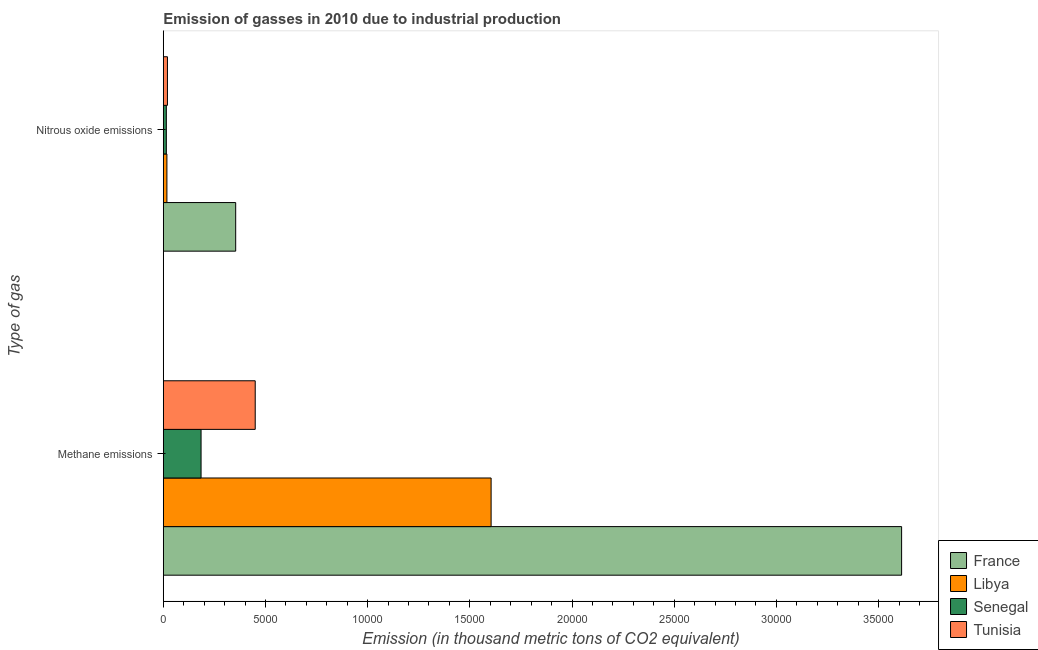Are the number of bars per tick equal to the number of legend labels?
Give a very brief answer. Yes. What is the label of the 1st group of bars from the top?
Ensure brevity in your answer.  Nitrous oxide emissions. What is the amount of nitrous oxide emissions in Tunisia?
Provide a short and direct response. 203.3. Across all countries, what is the maximum amount of nitrous oxide emissions?
Give a very brief answer. 3541.9. Across all countries, what is the minimum amount of methane emissions?
Keep it short and to the point. 1848. In which country was the amount of nitrous oxide emissions minimum?
Your response must be concise. Senegal. What is the total amount of nitrous oxide emissions in the graph?
Give a very brief answer. 4070.4. What is the difference between the amount of nitrous oxide emissions in France and that in Senegal?
Keep it short and to the point. 3393.3. What is the difference between the amount of nitrous oxide emissions in Libya and the amount of methane emissions in France?
Offer a very short reply. -3.59e+04. What is the average amount of nitrous oxide emissions per country?
Make the answer very short. 1017.6. What is the difference between the amount of methane emissions and amount of nitrous oxide emissions in Senegal?
Offer a terse response. 1699.4. What is the ratio of the amount of nitrous oxide emissions in France to that in Libya?
Provide a succinct answer. 20.06. Is the amount of methane emissions in Libya less than that in France?
Your answer should be very brief. Yes. In how many countries, is the amount of nitrous oxide emissions greater than the average amount of nitrous oxide emissions taken over all countries?
Give a very brief answer. 1. What does the 1st bar from the top in Methane emissions represents?
Offer a very short reply. Tunisia. What does the 2nd bar from the bottom in Nitrous oxide emissions represents?
Keep it short and to the point. Libya. How many bars are there?
Ensure brevity in your answer.  8. What is the difference between two consecutive major ticks on the X-axis?
Make the answer very short. 5000. Does the graph contain any zero values?
Give a very brief answer. No. How many legend labels are there?
Your answer should be compact. 4. What is the title of the graph?
Your answer should be compact. Emission of gasses in 2010 due to industrial production. Does "Trinidad and Tobago" appear as one of the legend labels in the graph?
Offer a very short reply. No. What is the label or title of the X-axis?
Provide a short and direct response. Emission (in thousand metric tons of CO2 equivalent). What is the label or title of the Y-axis?
Give a very brief answer. Type of gas. What is the Emission (in thousand metric tons of CO2 equivalent) in France in Methane emissions?
Provide a succinct answer. 3.61e+04. What is the Emission (in thousand metric tons of CO2 equivalent) in Libya in Methane emissions?
Ensure brevity in your answer.  1.60e+04. What is the Emission (in thousand metric tons of CO2 equivalent) of Senegal in Methane emissions?
Your response must be concise. 1848. What is the Emission (in thousand metric tons of CO2 equivalent) of Tunisia in Methane emissions?
Provide a short and direct response. 4497.8. What is the Emission (in thousand metric tons of CO2 equivalent) of France in Nitrous oxide emissions?
Ensure brevity in your answer.  3541.9. What is the Emission (in thousand metric tons of CO2 equivalent) of Libya in Nitrous oxide emissions?
Your answer should be very brief. 176.6. What is the Emission (in thousand metric tons of CO2 equivalent) in Senegal in Nitrous oxide emissions?
Make the answer very short. 148.6. What is the Emission (in thousand metric tons of CO2 equivalent) of Tunisia in Nitrous oxide emissions?
Your answer should be compact. 203.3. Across all Type of gas, what is the maximum Emission (in thousand metric tons of CO2 equivalent) in France?
Offer a terse response. 3.61e+04. Across all Type of gas, what is the maximum Emission (in thousand metric tons of CO2 equivalent) of Libya?
Offer a very short reply. 1.60e+04. Across all Type of gas, what is the maximum Emission (in thousand metric tons of CO2 equivalent) in Senegal?
Give a very brief answer. 1848. Across all Type of gas, what is the maximum Emission (in thousand metric tons of CO2 equivalent) in Tunisia?
Provide a succinct answer. 4497.8. Across all Type of gas, what is the minimum Emission (in thousand metric tons of CO2 equivalent) in France?
Your response must be concise. 3541.9. Across all Type of gas, what is the minimum Emission (in thousand metric tons of CO2 equivalent) in Libya?
Your response must be concise. 176.6. Across all Type of gas, what is the minimum Emission (in thousand metric tons of CO2 equivalent) in Senegal?
Provide a succinct answer. 148.6. Across all Type of gas, what is the minimum Emission (in thousand metric tons of CO2 equivalent) of Tunisia?
Offer a very short reply. 203.3. What is the total Emission (in thousand metric tons of CO2 equivalent) of France in the graph?
Your answer should be very brief. 3.97e+04. What is the total Emission (in thousand metric tons of CO2 equivalent) of Libya in the graph?
Give a very brief answer. 1.62e+04. What is the total Emission (in thousand metric tons of CO2 equivalent) of Senegal in the graph?
Keep it short and to the point. 1996.6. What is the total Emission (in thousand metric tons of CO2 equivalent) of Tunisia in the graph?
Provide a succinct answer. 4701.1. What is the difference between the Emission (in thousand metric tons of CO2 equivalent) of France in Methane emissions and that in Nitrous oxide emissions?
Provide a short and direct response. 3.26e+04. What is the difference between the Emission (in thousand metric tons of CO2 equivalent) in Libya in Methane emissions and that in Nitrous oxide emissions?
Your answer should be compact. 1.59e+04. What is the difference between the Emission (in thousand metric tons of CO2 equivalent) of Senegal in Methane emissions and that in Nitrous oxide emissions?
Your answer should be very brief. 1699.4. What is the difference between the Emission (in thousand metric tons of CO2 equivalent) in Tunisia in Methane emissions and that in Nitrous oxide emissions?
Ensure brevity in your answer.  4294.5. What is the difference between the Emission (in thousand metric tons of CO2 equivalent) of France in Methane emissions and the Emission (in thousand metric tons of CO2 equivalent) of Libya in Nitrous oxide emissions?
Provide a succinct answer. 3.59e+04. What is the difference between the Emission (in thousand metric tons of CO2 equivalent) of France in Methane emissions and the Emission (in thousand metric tons of CO2 equivalent) of Senegal in Nitrous oxide emissions?
Offer a terse response. 3.60e+04. What is the difference between the Emission (in thousand metric tons of CO2 equivalent) in France in Methane emissions and the Emission (in thousand metric tons of CO2 equivalent) in Tunisia in Nitrous oxide emissions?
Your response must be concise. 3.59e+04. What is the difference between the Emission (in thousand metric tons of CO2 equivalent) in Libya in Methane emissions and the Emission (in thousand metric tons of CO2 equivalent) in Senegal in Nitrous oxide emissions?
Your answer should be very brief. 1.59e+04. What is the difference between the Emission (in thousand metric tons of CO2 equivalent) in Libya in Methane emissions and the Emission (in thousand metric tons of CO2 equivalent) in Tunisia in Nitrous oxide emissions?
Your answer should be compact. 1.58e+04. What is the difference between the Emission (in thousand metric tons of CO2 equivalent) in Senegal in Methane emissions and the Emission (in thousand metric tons of CO2 equivalent) in Tunisia in Nitrous oxide emissions?
Give a very brief answer. 1644.7. What is the average Emission (in thousand metric tons of CO2 equivalent) of France per Type of gas?
Your response must be concise. 1.98e+04. What is the average Emission (in thousand metric tons of CO2 equivalent) of Libya per Type of gas?
Your answer should be very brief. 8108.25. What is the average Emission (in thousand metric tons of CO2 equivalent) in Senegal per Type of gas?
Ensure brevity in your answer.  998.3. What is the average Emission (in thousand metric tons of CO2 equivalent) of Tunisia per Type of gas?
Offer a terse response. 2350.55. What is the difference between the Emission (in thousand metric tons of CO2 equivalent) of France and Emission (in thousand metric tons of CO2 equivalent) of Libya in Methane emissions?
Your response must be concise. 2.01e+04. What is the difference between the Emission (in thousand metric tons of CO2 equivalent) in France and Emission (in thousand metric tons of CO2 equivalent) in Senegal in Methane emissions?
Your answer should be compact. 3.43e+04. What is the difference between the Emission (in thousand metric tons of CO2 equivalent) of France and Emission (in thousand metric tons of CO2 equivalent) of Tunisia in Methane emissions?
Keep it short and to the point. 3.16e+04. What is the difference between the Emission (in thousand metric tons of CO2 equivalent) in Libya and Emission (in thousand metric tons of CO2 equivalent) in Senegal in Methane emissions?
Provide a succinct answer. 1.42e+04. What is the difference between the Emission (in thousand metric tons of CO2 equivalent) of Libya and Emission (in thousand metric tons of CO2 equivalent) of Tunisia in Methane emissions?
Provide a short and direct response. 1.15e+04. What is the difference between the Emission (in thousand metric tons of CO2 equivalent) of Senegal and Emission (in thousand metric tons of CO2 equivalent) of Tunisia in Methane emissions?
Your answer should be very brief. -2649.8. What is the difference between the Emission (in thousand metric tons of CO2 equivalent) of France and Emission (in thousand metric tons of CO2 equivalent) of Libya in Nitrous oxide emissions?
Offer a terse response. 3365.3. What is the difference between the Emission (in thousand metric tons of CO2 equivalent) of France and Emission (in thousand metric tons of CO2 equivalent) of Senegal in Nitrous oxide emissions?
Your answer should be compact. 3393.3. What is the difference between the Emission (in thousand metric tons of CO2 equivalent) in France and Emission (in thousand metric tons of CO2 equivalent) in Tunisia in Nitrous oxide emissions?
Ensure brevity in your answer.  3338.6. What is the difference between the Emission (in thousand metric tons of CO2 equivalent) in Libya and Emission (in thousand metric tons of CO2 equivalent) in Tunisia in Nitrous oxide emissions?
Offer a very short reply. -26.7. What is the difference between the Emission (in thousand metric tons of CO2 equivalent) in Senegal and Emission (in thousand metric tons of CO2 equivalent) in Tunisia in Nitrous oxide emissions?
Ensure brevity in your answer.  -54.7. What is the ratio of the Emission (in thousand metric tons of CO2 equivalent) of France in Methane emissions to that in Nitrous oxide emissions?
Your answer should be compact. 10.2. What is the ratio of the Emission (in thousand metric tons of CO2 equivalent) of Libya in Methane emissions to that in Nitrous oxide emissions?
Offer a terse response. 90.83. What is the ratio of the Emission (in thousand metric tons of CO2 equivalent) of Senegal in Methane emissions to that in Nitrous oxide emissions?
Provide a short and direct response. 12.44. What is the ratio of the Emission (in thousand metric tons of CO2 equivalent) of Tunisia in Methane emissions to that in Nitrous oxide emissions?
Provide a succinct answer. 22.12. What is the difference between the highest and the second highest Emission (in thousand metric tons of CO2 equivalent) of France?
Your answer should be compact. 3.26e+04. What is the difference between the highest and the second highest Emission (in thousand metric tons of CO2 equivalent) in Libya?
Keep it short and to the point. 1.59e+04. What is the difference between the highest and the second highest Emission (in thousand metric tons of CO2 equivalent) in Senegal?
Ensure brevity in your answer.  1699.4. What is the difference between the highest and the second highest Emission (in thousand metric tons of CO2 equivalent) in Tunisia?
Your answer should be compact. 4294.5. What is the difference between the highest and the lowest Emission (in thousand metric tons of CO2 equivalent) in France?
Your answer should be compact. 3.26e+04. What is the difference between the highest and the lowest Emission (in thousand metric tons of CO2 equivalent) of Libya?
Offer a very short reply. 1.59e+04. What is the difference between the highest and the lowest Emission (in thousand metric tons of CO2 equivalent) of Senegal?
Your response must be concise. 1699.4. What is the difference between the highest and the lowest Emission (in thousand metric tons of CO2 equivalent) in Tunisia?
Your answer should be compact. 4294.5. 